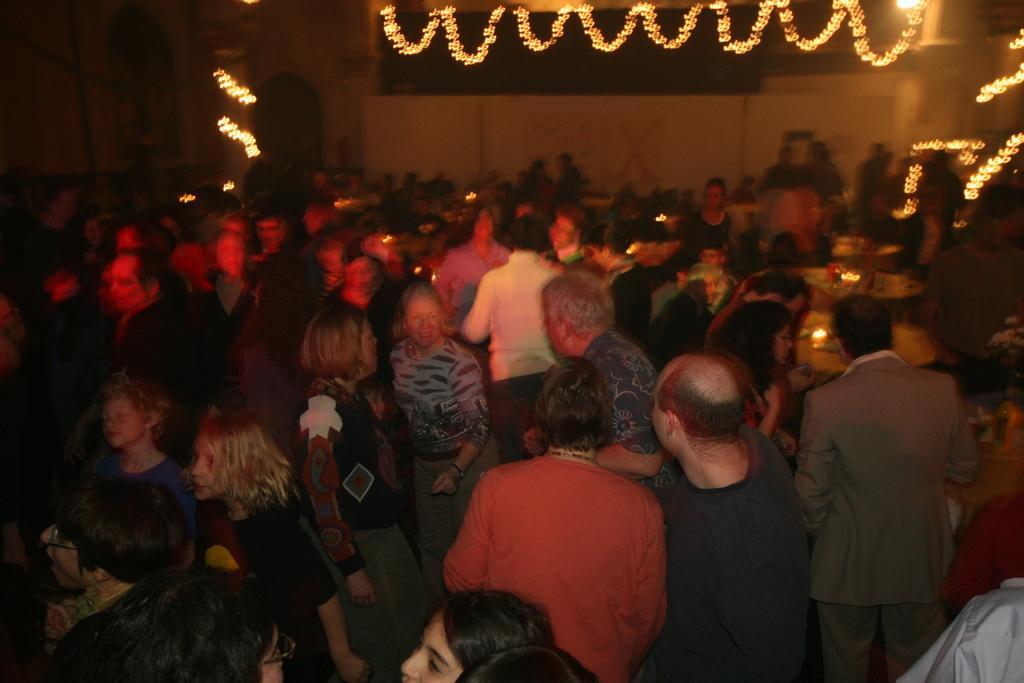How would you summarize this image in a sentence or two? In this image we can see a group of people, near that we can see tables and few objects on it, we can see the pillar, near that we can see some lights, we can see the wall in the background. 